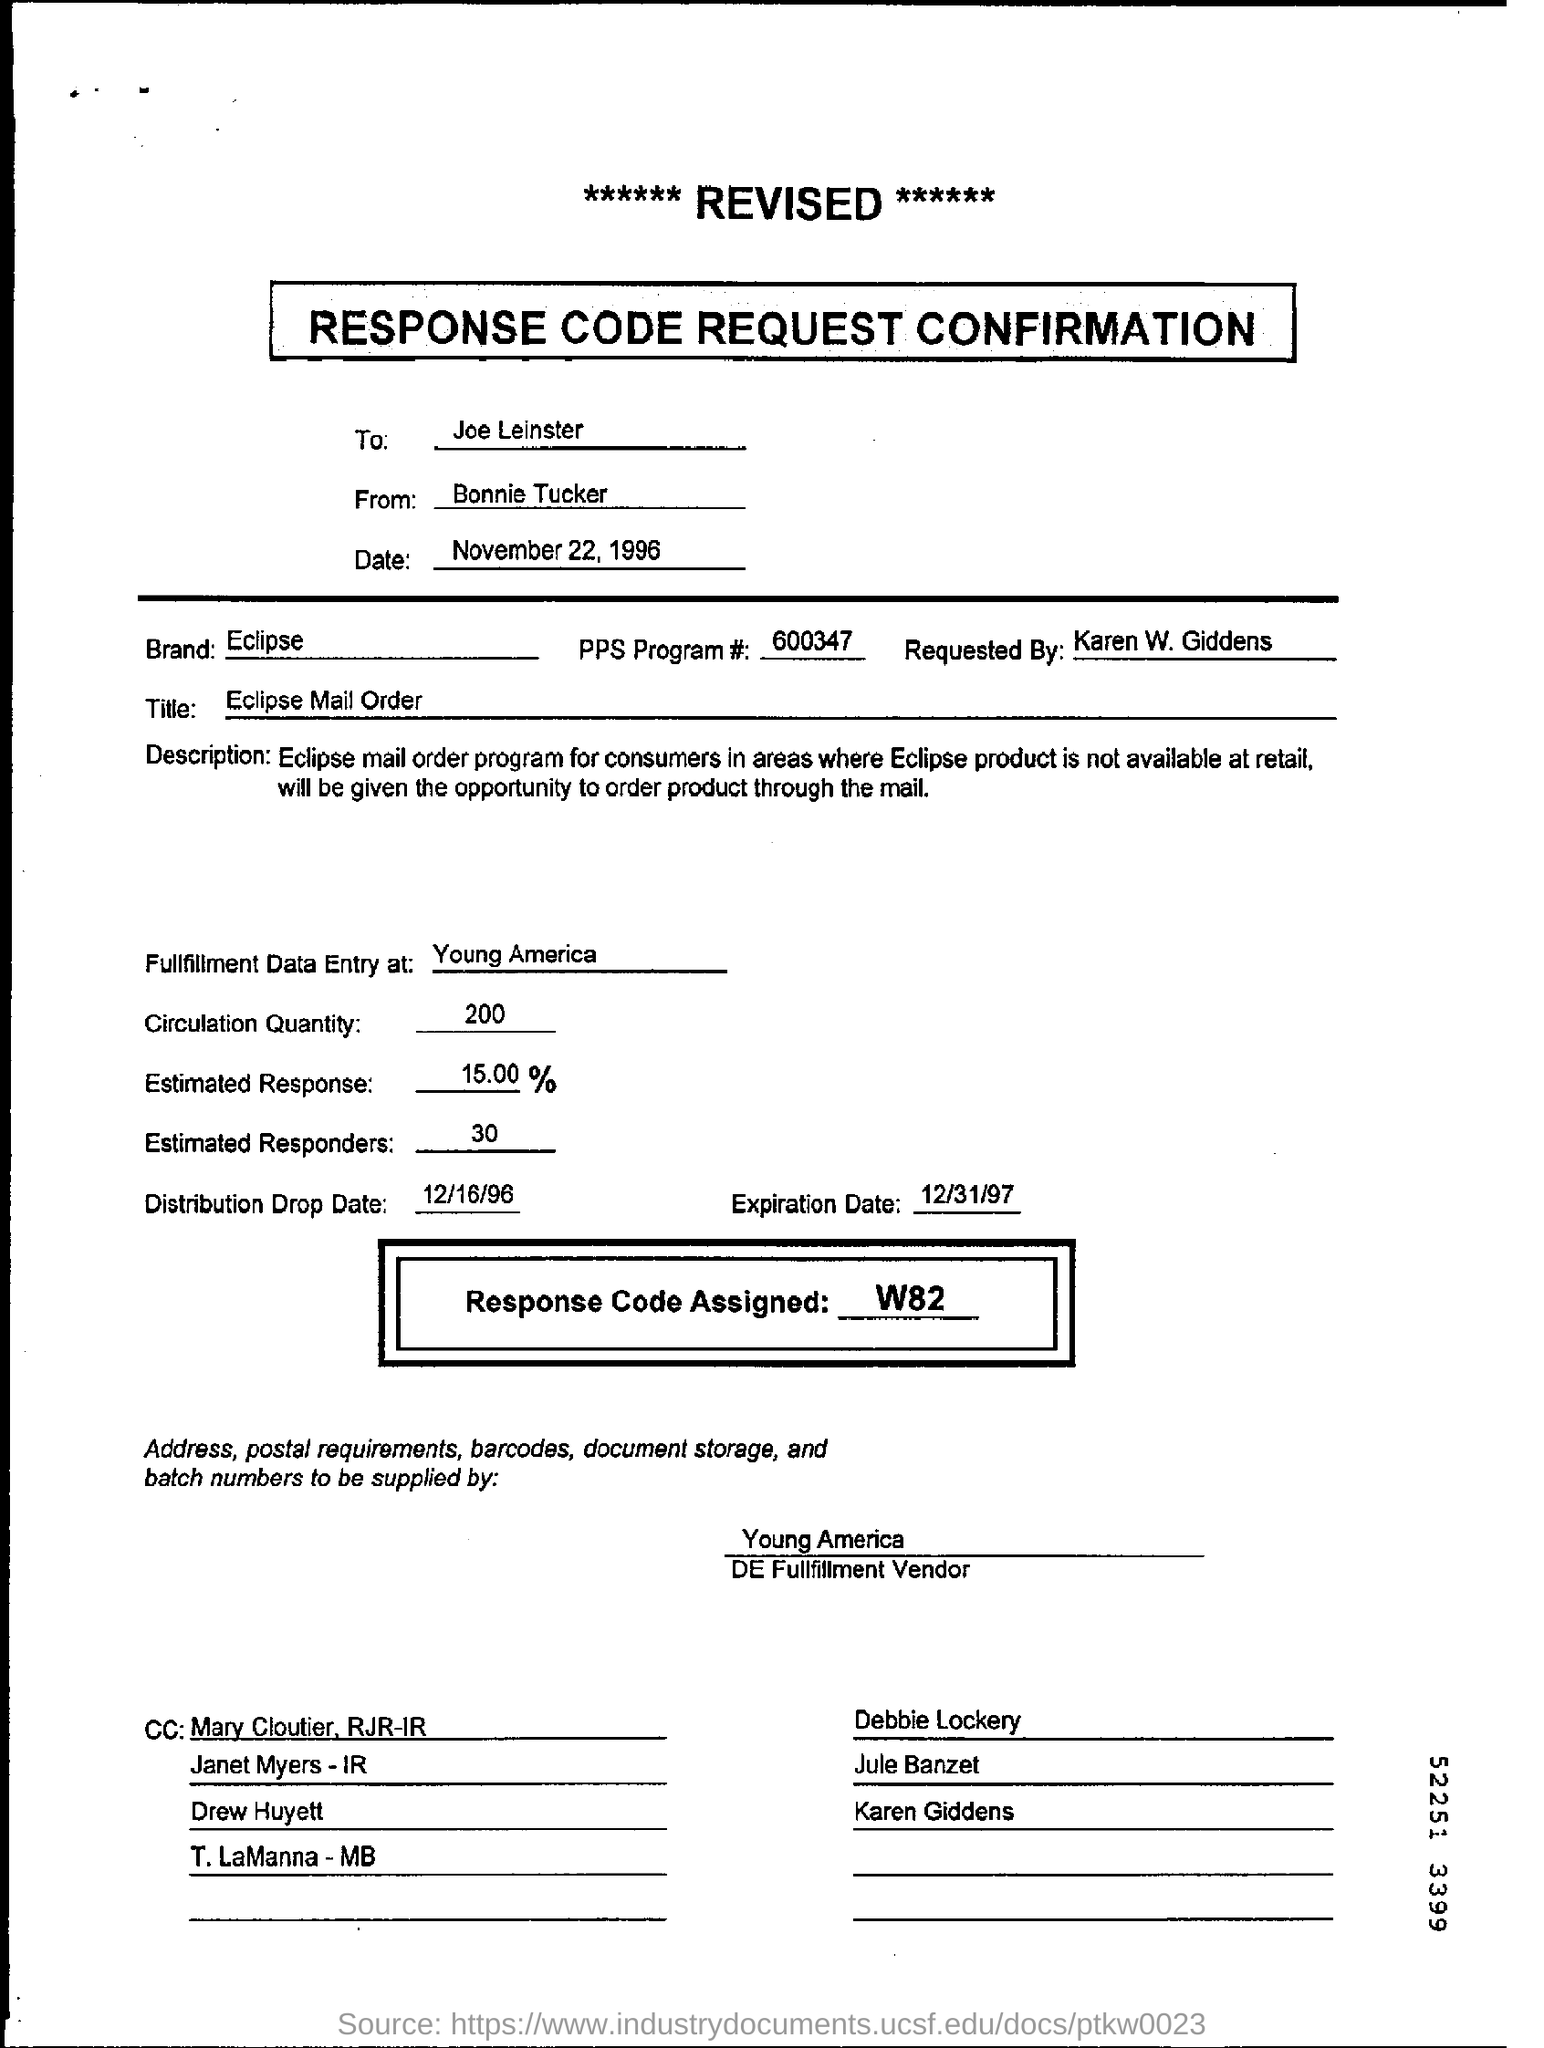List a handful of essential elements in this visual. The date mentioned is November 22, 1996. This document is addressed to Joe Leinster. 